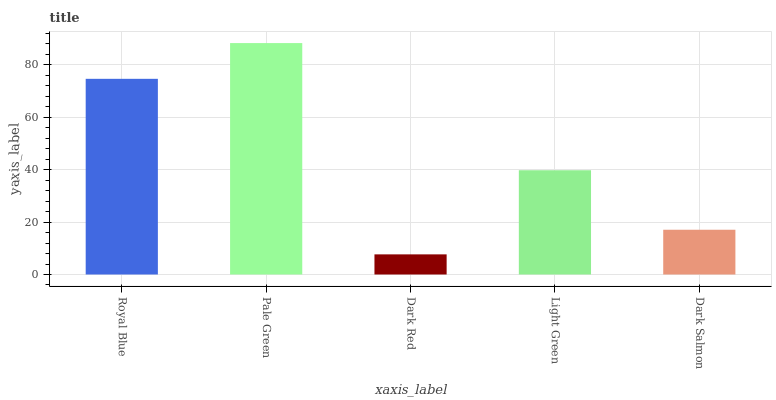Is Pale Green the minimum?
Answer yes or no. No. Is Dark Red the maximum?
Answer yes or no. No. Is Pale Green greater than Dark Red?
Answer yes or no. Yes. Is Dark Red less than Pale Green?
Answer yes or no. Yes. Is Dark Red greater than Pale Green?
Answer yes or no. No. Is Pale Green less than Dark Red?
Answer yes or no. No. Is Light Green the high median?
Answer yes or no. Yes. Is Light Green the low median?
Answer yes or no. Yes. Is Dark Salmon the high median?
Answer yes or no. No. Is Pale Green the low median?
Answer yes or no. No. 